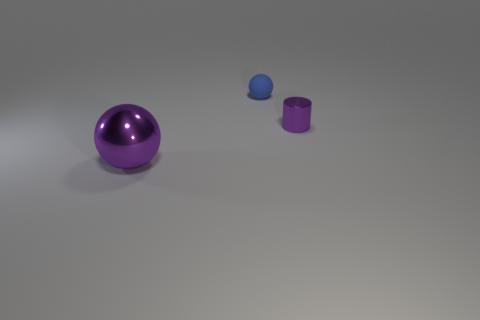There is a blue ball; are there any purple metal objects in front of it? yes 